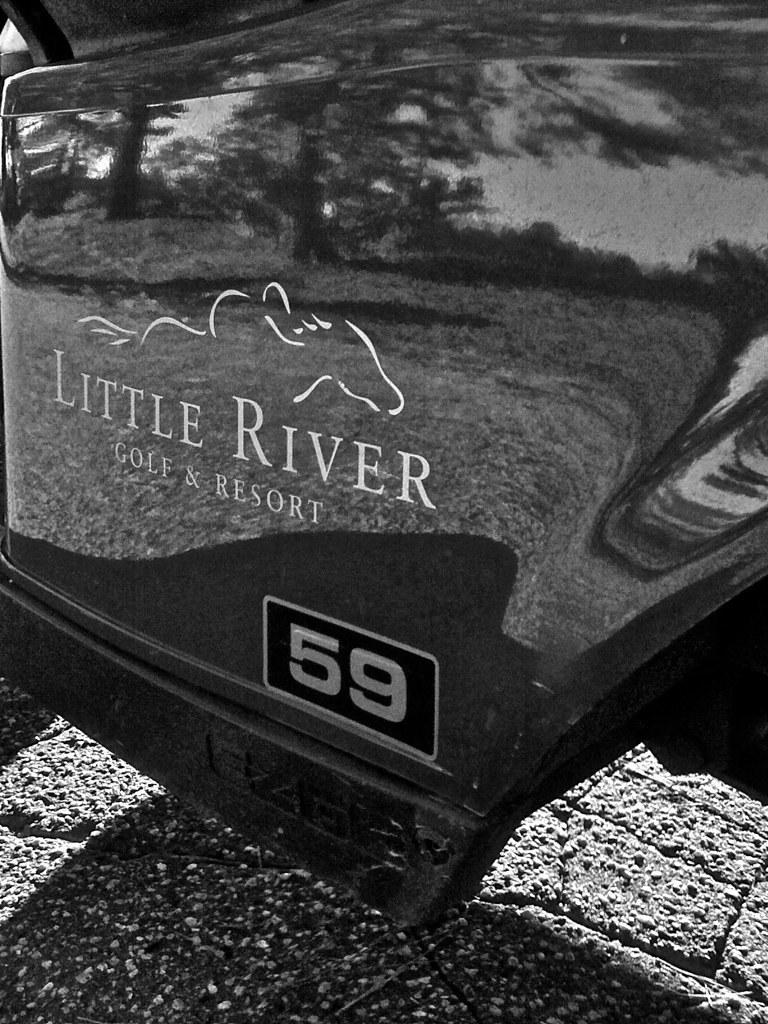What is the main subject of the image? The main subject of the image is a door of a vehicle. What can be seen on the vehicle door? There is text and a picture present on the vehicle door. What is the existence of the minute fiction in the image? There is no mention of existence, minute, or fiction in the image. The image only features a vehicle door with text and a picture. 